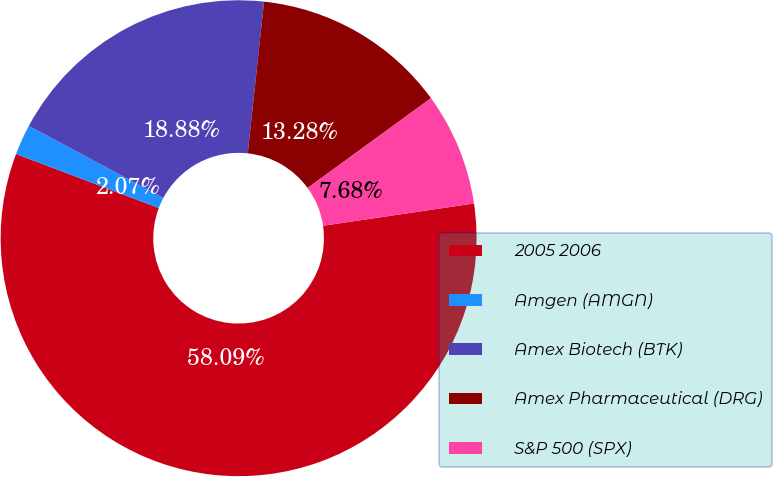Convert chart to OTSL. <chart><loc_0><loc_0><loc_500><loc_500><pie_chart><fcel>2005 2006<fcel>Amgen (AMGN)<fcel>Amex Biotech (BTK)<fcel>Amex Pharmaceutical (DRG)<fcel>S&P 500 (SPX)<nl><fcel>58.09%<fcel>2.07%<fcel>18.88%<fcel>13.28%<fcel>7.68%<nl></chart> 